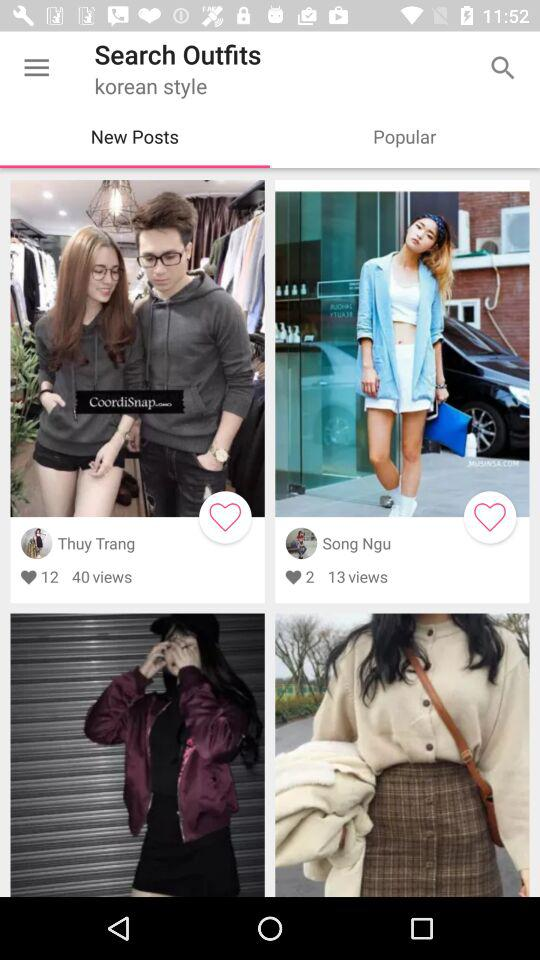Which tab is selected? The selected tab is New Posts. 